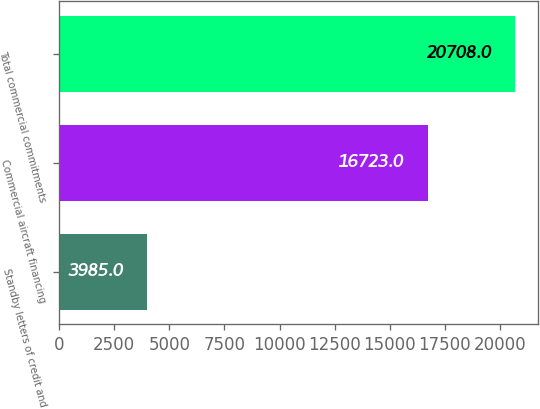Convert chart. <chart><loc_0><loc_0><loc_500><loc_500><bar_chart><fcel>Standby letters of credit and<fcel>Commercial aircraft financing<fcel>Total commercial commitments<nl><fcel>3985<fcel>16723<fcel>20708<nl></chart> 